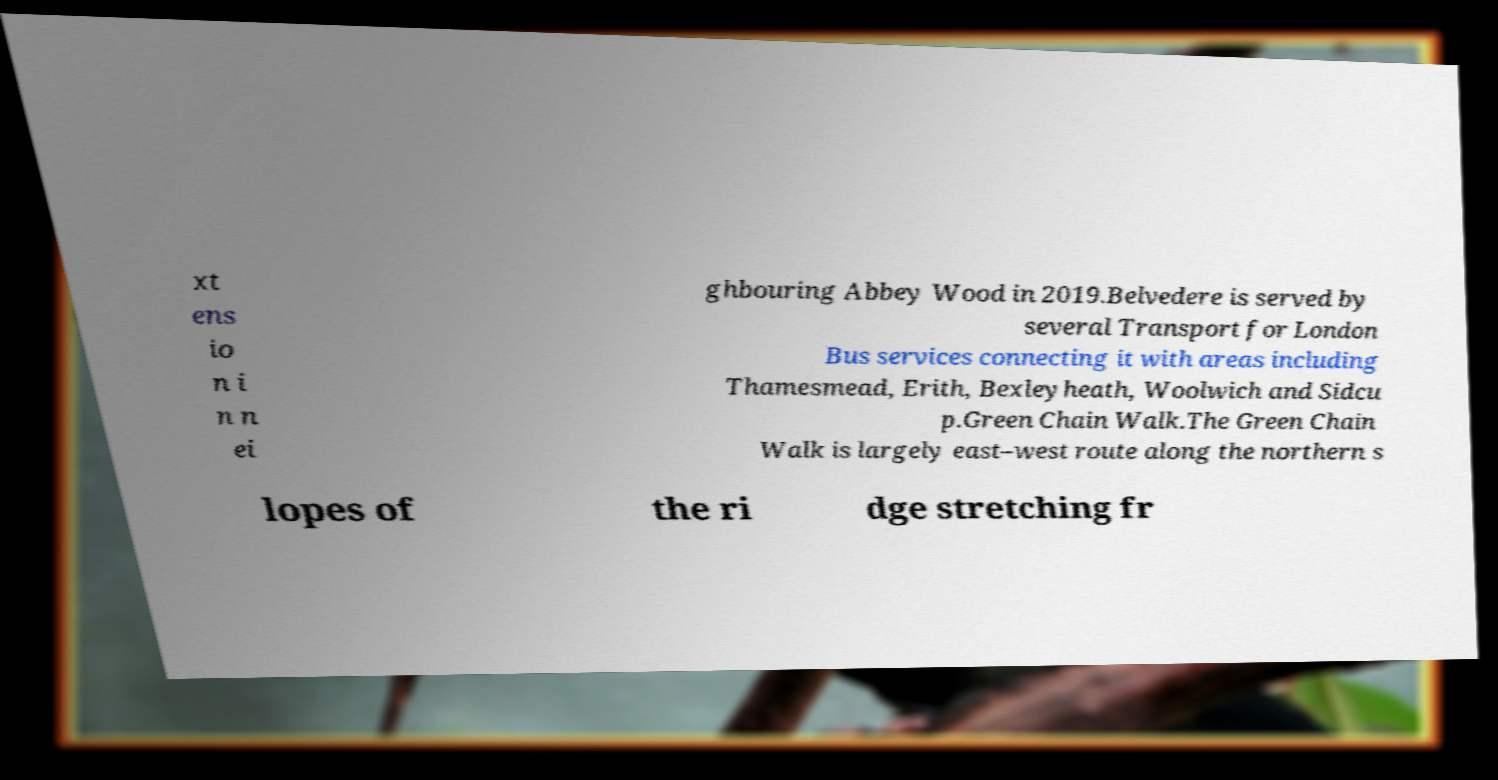Can you accurately transcribe the text from the provided image for me? xt ens io n i n n ei ghbouring Abbey Wood in 2019.Belvedere is served by several Transport for London Bus services connecting it with areas including Thamesmead, Erith, Bexleyheath, Woolwich and Sidcu p.Green Chain Walk.The Green Chain Walk is largely east–west route along the northern s lopes of the ri dge stretching fr 